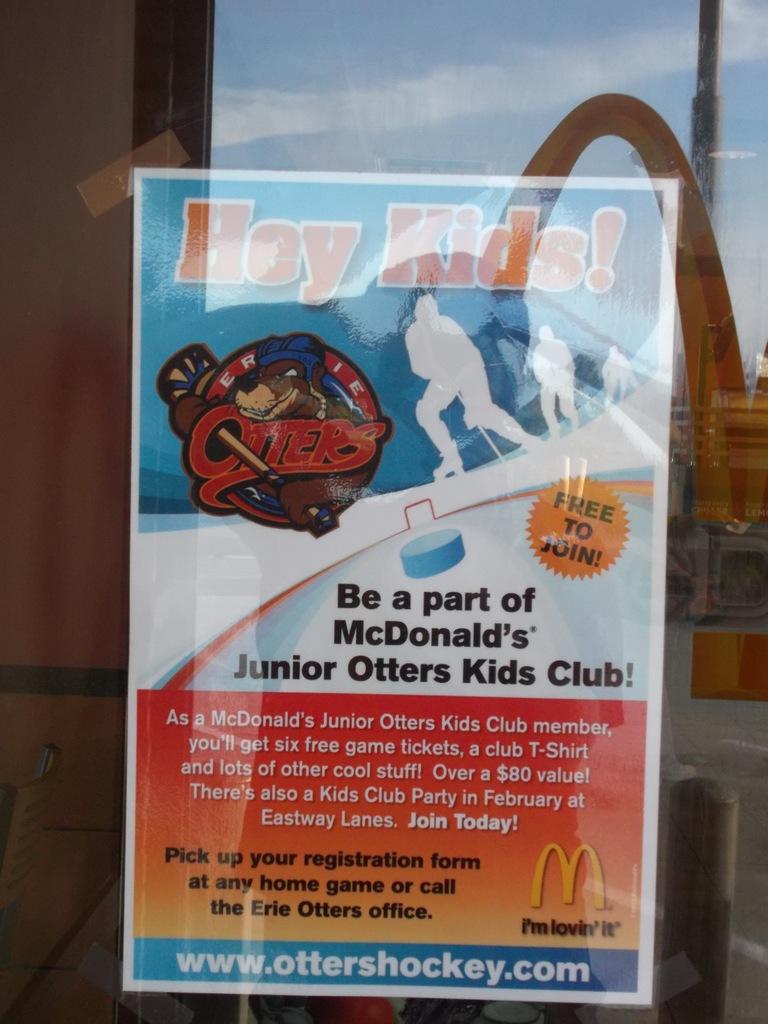What is the otters club?
Make the answer very short. Kids club. How much is the value worth for this club?
Your answer should be very brief. $80. 